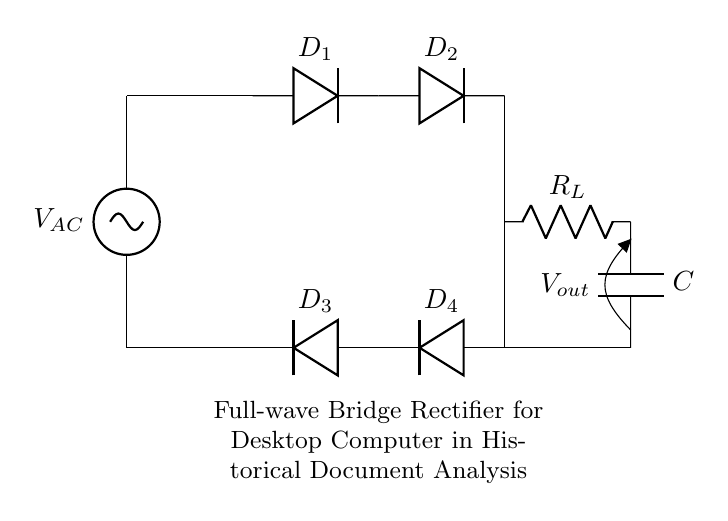What is the type of rectifier used in this circuit? The circuit diagram displays a full-wave bridge rectifier, indicated by the arrangement of four diodes configured in a bridge formation.
Answer: full-wave bridge rectifier How many diodes are present in this circuit? The circuit shows four diodes connected in a specific arrangement for rectification, clearly labeled as D1, D2, D3, and D4.
Answer: four What is the function of the capacitor in this circuit? The capacitor is connected in parallel with the load resistor to smooth out the output voltage, reducing ripple and providing a more stable DC output.
Answer: smoothing What is the role of the load resistor? The load resistor R_L is the component where the rectified output voltage is delivered, representing the load that the circuit is designed to power for historical document analysis.
Answer: load What are the input and output voltage labels in this circuit? The AC source is labeled V_AC as the input voltage, while the output voltage is referenced as V_out where the load receives the DC power.
Answer: V_AC and V_out What happens to the current during the positive and negative cycles in this circuit? During both the positive and negative cycles of the AC input, the bridge rectifier allows current to flow through the load resistor in a single direction, thereby converting AC to DC.
Answer: flows unidirectionally What component provides the rectified DC output? The output of the circuit is taken across the load resistor R_L after rectification and smoothing, which delivers the usable DC voltage for the desktop computer.
Answer: load resistor R_L 